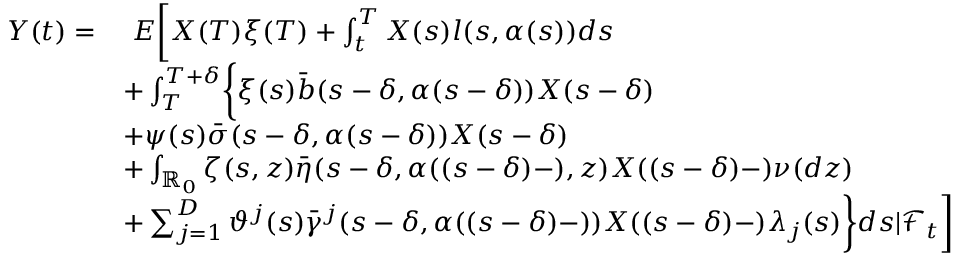Convert formula to latex. <formula><loc_0><loc_0><loc_500><loc_500>\begin{array} { r l } { Y ( t ) = } & { \ E \left [ X ( T ) \xi ( T ) + \int _ { t } ^ { T } X ( s ) l ( s , \alpha ( s ) ) d s } \\ & { + \int _ { T } ^ { T + \delta } \left \{ \xi ( s ) \bar { b } ( s - \delta , \alpha ( s - \delta ) ) X ( s - \delta ) } \\ & { + \psi ( s ) \bar { \sigma } ( s - \delta , \alpha ( s - \delta ) ) X ( s - \delta ) } \\ & { + \int _ { \mathbb { R } _ { 0 } } \zeta ( s , z ) \bar { \eta } ( s - \delta , \alpha ( ( s - \delta ) - ) , z ) X ( ( s - \delta ) - ) \nu ( d z ) } \\ & { + \sum _ { j = 1 } ^ { D } \vartheta ^ { j } ( s ) \bar { \gamma } ^ { j } ( s - \delta , \alpha ( ( s - \delta ) - ) ) X ( ( s - \delta ) - ) \lambda _ { j } ( s ) \right \} d s | \mathcal { F } _ { t } \right ] } \end{array}</formula> 